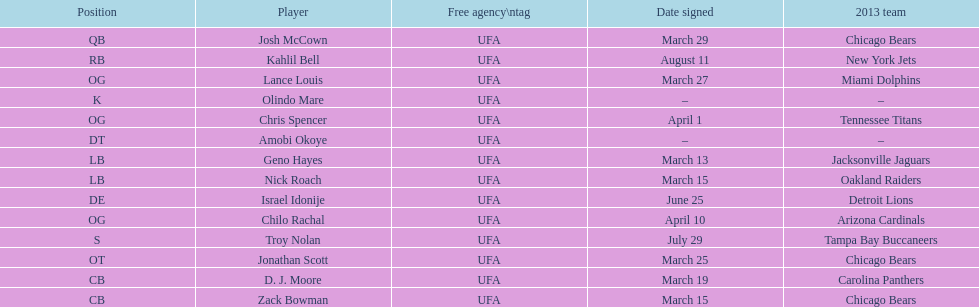The only player to sign in july? Troy Nolan. 